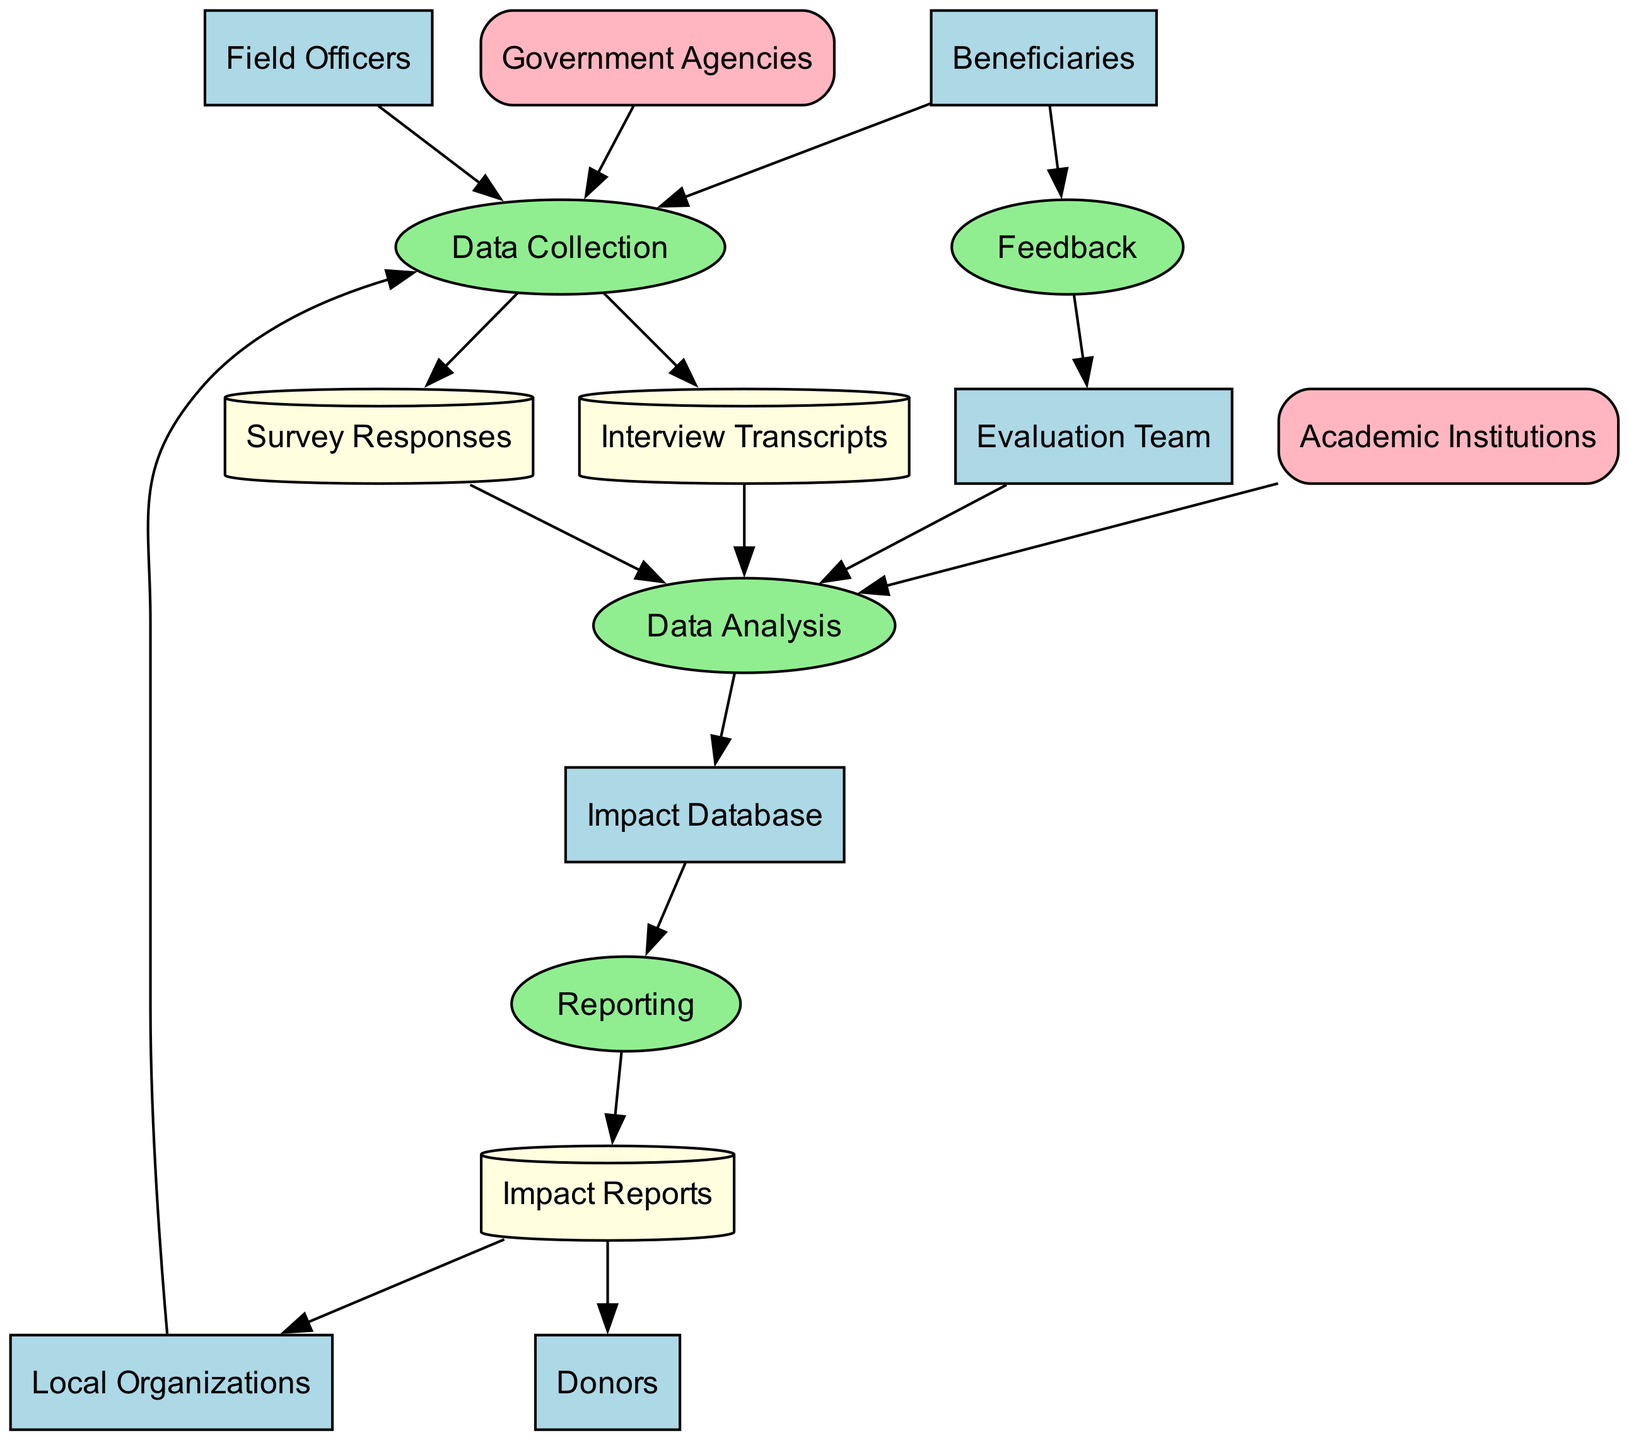What are the beneficiaries involved in the cultural exchange program? The beneficiaries are participants in the program, specifically local community members and foreign visitors, as indicated in the entities section.
Answer: Participants in the cultural exchange program, including local community members and foreign visitors How many external entities are shown in the diagram? By reviewing the external entities listed in the diagram, we can identify that there are two: Government Agencies and Academic Institutions.
Answer: Two What process comes directly after data collection? Following the flow from "Data Collection," the next process that emerges is "Data Analysis." This is clearly indicated by the directed edge connecting these two nodes.
Answer: Data Analysis Which entities provide data for the data collection process? The data collection process receives input from three specific entities: Beneficiaries, Field Officers, and Local Organizations, as evidenced by the edges leading to the "Data Collection" process from these nodes.
Answer: Beneficiaries, Field Officers, and Local Organizations What type of information is stored in the Impact Database? The "Impact Database" is defined as a central repository for all collected data regarding program impact, based on the description provided in the entities section of the diagram.
Answer: Collected data on program impact How does the feedback process connect to the evaluation team? The "Feedback" process connects to the "Evaluation Team"; this is shown by the directed edge leading from the "Feedback" node to the "Evaluation Team," indicating indeed that feedback informs the evaluation team.
Answer: By gathering feedback from beneficiaries What is the relationship between the data analysis and the reporting process? The connection is established by noting that "Data Analysis" feeds output into "Reporting," as illustrated by the edge that leads from the analysis process to the reporting process, indicating that the analysis results are compiled in the reports.
Answer: Data Analysis informs Reporting What type of data can be found in the Interview Transcripts data store? The "Interview Transcripts" data store is specified to contain qualitative data from interviews conducted with community members and local organizations, as stated in its description.
Answer: Qualitative data from interviews Which group is responsible for assessing the impact of the cultural exchange program? The "Evaluation Team" is designated as the group responsible for this task, as described in the entities section of the diagram.
Answer: Evaluation Team 